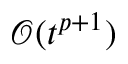Convert formula to latex. <formula><loc_0><loc_0><loc_500><loc_500>\mathcal { O } ( t ^ { p + 1 } )</formula> 